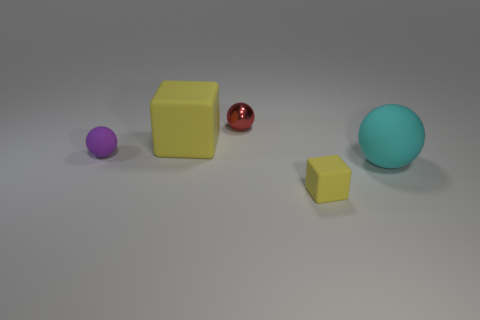Subtract 1 spheres. How many spheres are left? 2 Add 4 tiny cyan rubber cylinders. How many objects exist? 9 Subtract all spheres. How many objects are left? 2 Subtract all shiny spheres. Subtract all metallic things. How many objects are left? 3 Add 2 tiny yellow cubes. How many tiny yellow cubes are left? 3 Add 1 cyan matte balls. How many cyan matte balls exist? 2 Subtract 0 brown cylinders. How many objects are left? 5 